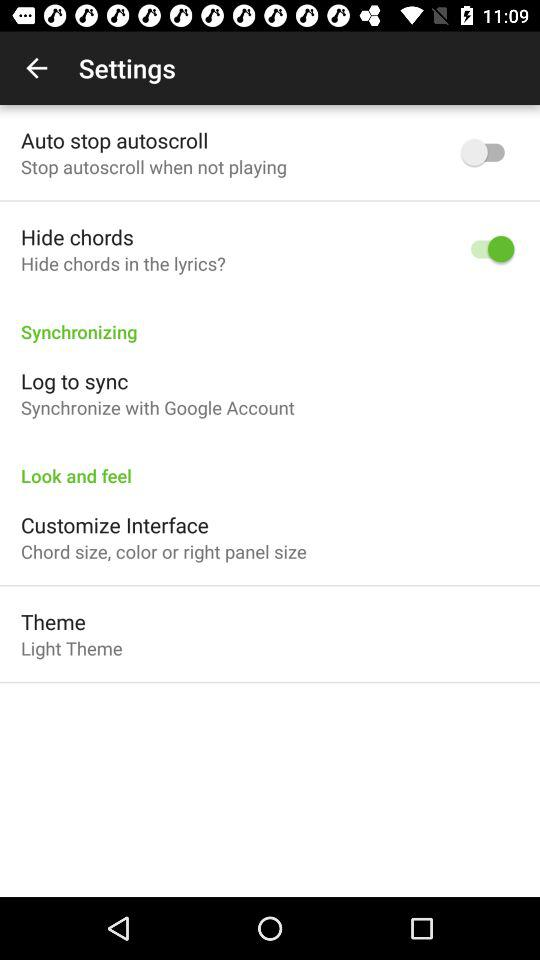What account is used to synchronize? To synchronize, "Google" account is used. 